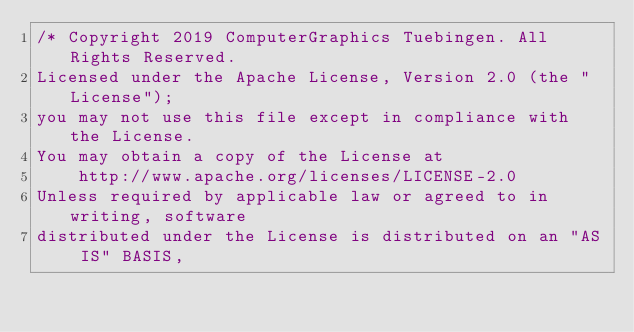<code> <loc_0><loc_0><loc_500><loc_500><_Cuda_>/* Copyright 2019 ComputerGraphics Tuebingen. All Rights Reserved.
Licensed under the Apache License, Version 2.0 (the "License");
you may not use this file except in compliance with the License.
You may obtain a copy of the License at
    http://www.apache.org/licenses/LICENSE-2.0
Unless required by applicable law or agreed to in writing, software
distributed under the License is distributed on an "AS IS" BASIS,</code> 